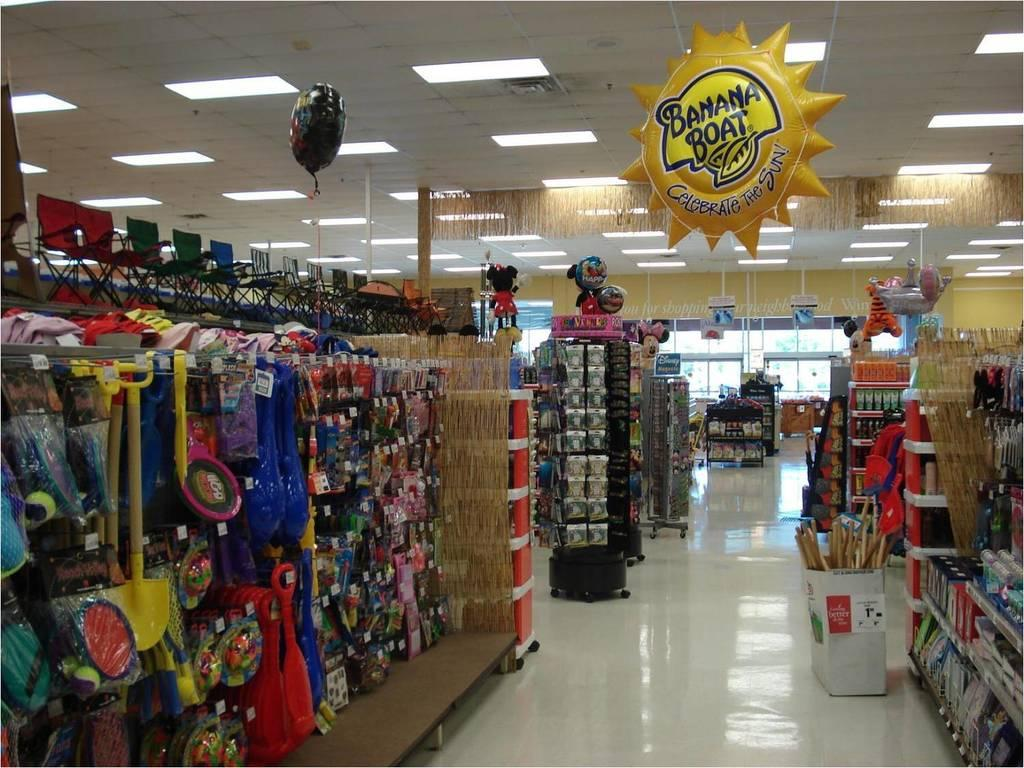Provide a one-sentence caption for the provided image. An aisle of a store has a yellow sun hanging from the ceiling that reads, "Banana Boat.". 